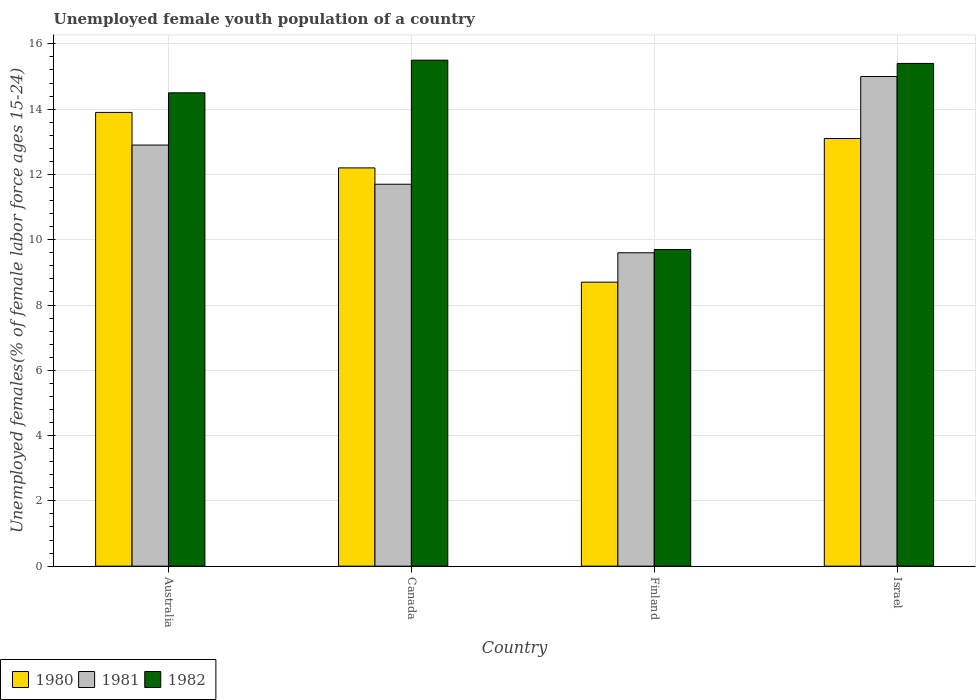How many different coloured bars are there?
Keep it short and to the point. 3. How many groups of bars are there?
Ensure brevity in your answer.  4. Are the number of bars per tick equal to the number of legend labels?
Provide a short and direct response. Yes. How many bars are there on the 1st tick from the left?
Give a very brief answer. 3. How many bars are there on the 1st tick from the right?
Provide a succinct answer. 3. What is the label of the 2nd group of bars from the left?
Offer a very short reply. Canada. Across all countries, what is the minimum percentage of unemployed female youth population in 1982?
Your response must be concise. 9.7. In which country was the percentage of unemployed female youth population in 1982 minimum?
Your answer should be compact. Finland. What is the total percentage of unemployed female youth population in 1982 in the graph?
Provide a short and direct response. 55.1. What is the difference between the percentage of unemployed female youth population in 1980 in Australia and that in Israel?
Offer a terse response. 0.8. What is the difference between the percentage of unemployed female youth population in 1981 in Australia and the percentage of unemployed female youth population in 1982 in Finland?
Offer a terse response. 3.2. What is the average percentage of unemployed female youth population in 1982 per country?
Ensure brevity in your answer.  13.77. What is the difference between the percentage of unemployed female youth population of/in 1982 and percentage of unemployed female youth population of/in 1980 in Finland?
Offer a very short reply. 1. In how many countries, is the percentage of unemployed female youth population in 1980 greater than 1.6 %?
Provide a short and direct response. 4. What is the ratio of the percentage of unemployed female youth population in 1981 in Canada to that in Israel?
Keep it short and to the point. 0.78. What is the difference between the highest and the second highest percentage of unemployed female youth population in 1982?
Your answer should be very brief. 0.9. What is the difference between the highest and the lowest percentage of unemployed female youth population in 1981?
Provide a succinct answer. 5.4. What does the 3rd bar from the left in Israel represents?
Give a very brief answer. 1982. What does the 1st bar from the right in Finland represents?
Make the answer very short. 1982. Is it the case that in every country, the sum of the percentage of unemployed female youth population in 1981 and percentage of unemployed female youth population in 1982 is greater than the percentage of unemployed female youth population in 1980?
Offer a very short reply. Yes. How many countries are there in the graph?
Your answer should be compact. 4. What is the difference between two consecutive major ticks on the Y-axis?
Your answer should be very brief. 2. Does the graph contain any zero values?
Ensure brevity in your answer.  No. Where does the legend appear in the graph?
Keep it short and to the point. Bottom left. How are the legend labels stacked?
Provide a succinct answer. Horizontal. What is the title of the graph?
Offer a terse response. Unemployed female youth population of a country. Does "1965" appear as one of the legend labels in the graph?
Give a very brief answer. No. What is the label or title of the X-axis?
Your answer should be compact. Country. What is the label or title of the Y-axis?
Ensure brevity in your answer.  Unemployed females(% of female labor force ages 15-24). What is the Unemployed females(% of female labor force ages 15-24) of 1980 in Australia?
Offer a very short reply. 13.9. What is the Unemployed females(% of female labor force ages 15-24) of 1981 in Australia?
Make the answer very short. 12.9. What is the Unemployed females(% of female labor force ages 15-24) of 1982 in Australia?
Provide a short and direct response. 14.5. What is the Unemployed females(% of female labor force ages 15-24) of 1980 in Canada?
Make the answer very short. 12.2. What is the Unemployed females(% of female labor force ages 15-24) of 1981 in Canada?
Offer a very short reply. 11.7. What is the Unemployed females(% of female labor force ages 15-24) in 1982 in Canada?
Provide a succinct answer. 15.5. What is the Unemployed females(% of female labor force ages 15-24) in 1980 in Finland?
Offer a very short reply. 8.7. What is the Unemployed females(% of female labor force ages 15-24) of 1981 in Finland?
Offer a terse response. 9.6. What is the Unemployed females(% of female labor force ages 15-24) in 1982 in Finland?
Offer a very short reply. 9.7. What is the Unemployed females(% of female labor force ages 15-24) of 1980 in Israel?
Your response must be concise. 13.1. What is the Unemployed females(% of female labor force ages 15-24) of 1982 in Israel?
Make the answer very short. 15.4. Across all countries, what is the maximum Unemployed females(% of female labor force ages 15-24) of 1980?
Keep it short and to the point. 13.9. Across all countries, what is the maximum Unemployed females(% of female labor force ages 15-24) of 1981?
Keep it short and to the point. 15. Across all countries, what is the maximum Unemployed females(% of female labor force ages 15-24) of 1982?
Provide a short and direct response. 15.5. Across all countries, what is the minimum Unemployed females(% of female labor force ages 15-24) in 1980?
Your response must be concise. 8.7. Across all countries, what is the minimum Unemployed females(% of female labor force ages 15-24) in 1981?
Make the answer very short. 9.6. Across all countries, what is the minimum Unemployed females(% of female labor force ages 15-24) of 1982?
Your answer should be very brief. 9.7. What is the total Unemployed females(% of female labor force ages 15-24) in 1980 in the graph?
Provide a short and direct response. 47.9. What is the total Unemployed females(% of female labor force ages 15-24) of 1981 in the graph?
Ensure brevity in your answer.  49.2. What is the total Unemployed females(% of female labor force ages 15-24) in 1982 in the graph?
Your answer should be compact. 55.1. What is the difference between the Unemployed females(% of female labor force ages 15-24) of 1980 in Australia and that in Canada?
Offer a terse response. 1.7. What is the difference between the Unemployed females(% of female labor force ages 15-24) in 1981 in Australia and that in Canada?
Give a very brief answer. 1.2. What is the difference between the Unemployed females(% of female labor force ages 15-24) of 1980 in Australia and that in Finland?
Keep it short and to the point. 5.2. What is the difference between the Unemployed females(% of female labor force ages 15-24) in 1982 in Australia and that in Finland?
Provide a succinct answer. 4.8. What is the difference between the Unemployed females(% of female labor force ages 15-24) in 1980 in Australia and that in Israel?
Your response must be concise. 0.8. What is the difference between the Unemployed females(% of female labor force ages 15-24) of 1981 in Canada and that in Finland?
Keep it short and to the point. 2.1. What is the difference between the Unemployed females(% of female labor force ages 15-24) of 1982 in Canada and that in Finland?
Your answer should be very brief. 5.8. What is the difference between the Unemployed females(% of female labor force ages 15-24) of 1980 in Canada and that in Israel?
Your response must be concise. -0.9. What is the difference between the Unemployed females(% of female labor force ages 15-24) in 1981 in Canada and that in Israel?
Offer a very short reply. -3.3. What is the difference between the Unemployed females(% of female labor force ages 15-24) of 1982 in Canada and that in Israel?
Keep it short and to the point. 0.1. What is the difference between the Unemployed females(% of female labor force ages 15-24) of 1981 in Australia and the Unemployed females(% of female labor force ages 15-24) of 1982 in Canada?
Your answer should be compact. -2.6. What is the difference between the Unemployed females(% of female labor force ages 15-24) in 1980 in Australia and the Unemployed females(% of female labor force ages 15-24) in 1981 in Finland?
Your answer should be compact. 4.3. What is the difference between the Unemployed females(% of female labor force ages 15-24) in 1980 in Australia and the Unemployed females(% of female labor force ages 15-24) in 1982 in Finland?
Keep it short and to the point. 4.2. What is the difference between the Unemployed females(% of female labor force ages 15-24) in 1981 in Australia and the Unemployed females(% of female labor force ages 15-24) in 1982 in Finland?
Your answer should be very brief. 3.2. What is the difference between the Unemployed females(% of female labor force ages 15-24) in 1981 in Australia and the Unemployed females(% of female labor force ages 15-24) in 1982 in Israel?
Offer a terse response. -2.5. What is the difference between the Unemployed females(% of female labor force ages 15-24) of 1980 in Canada and the Unemployed females(% of female labor force ages 15-24) of 1981 in Finland?
Your answer should be compact. 2.6. What is the difference between the Unemployed females(% of female labor force ages 15-24) in 1980 in Canada and the Unemployed females(% of female labor force ages 15-24) in 1982 in Israel?
Ensure brevity in your answer.  -3.2. What is the difference between the Unemployed females(% of female labor force ages 15-24) of 1981 in Canada and the Unemployed females(% of female labor force ages 15-24) of 1982 in Israel?
Offer a very short reply. -3.7. What is the difference between the Unemployed females(% of female labor force ages 15-24) of 1980 in Finland and the Unemployed females(% of female labor force ages 15-24) of 1981 in Israel?
Make the answer very short. -6.3. What is the difference between the Unemployed females(% of female labor force ages 15-24) of 1981 in Finland and the Unemployed females(% of female labor force ages 15-24) of 1982 in Israel?
Your answer should be compact. -5.8. What is the average Unemployed females(% of female labor force ages 15-24) of 1980 per country?
Ensure brevity in your answer.  11.97. What is the average Unemployed females(% of female labor force ages 15-24) of 1982 per country?
Offer a very short reply. 13.78. What is the difference between the Unemployed females(% of female labor force ages 15-24) of 1980 and Unemployed females(% of female labor force ages 15-24) of 1981 in Australia?
Your answer should be very brief. 1. What is the difference between the Unemployed females(% of female labor force ages 15-24) in 1981 and Unemployed females(% of female labor force ages 15-24) in 1982 in Australia?
Make the answer very short. -1.6. What is the difference between the Unemployed females(% of female labor force ages 15-24) of 1981 and Unemployed females(% of female labor force ages 15-24) of 1982 in Canada?
Provide a succinct answer. -3.8. What is the difference between the Unemployed females(% of female labor force ages 15-24) of 1980 and Unemployed females(% of female labor force ages 15-24) of 1982 in Finland?
Offer a terse response. -1. What is the difference between the Unemployed females(% of female labor force ages 15-24) in 1981 and Unemployed females(% of female labor force ages 15-24) in 1982 in Finland?
Offer a terse response. -0.1. What is the difference between the Unemployed females(% of female labor force ages 15-24) in 1980 and Unemployed females(% of female labor force ages 15-24) in 1981 in Israel?
Your answer should be very brief. -1.9. What is the ratio of the Unemployed females(% of female labor force ages 15-24) in 1980 in Australia to that in Canada?
Provide a short and direct response. 1.14. What is the ratio of the Unemployed females(% of female labor force ages 15-24) in 1981 in Australia to that in Canada?
Offer a very short reply. 1.1. What is the ratio of the Unemployed females(% of female labor force ages 15-24) in 1982 in Australia to that in Canada?
Give a very brief answer. 0.94. What is the ratio of the Unemployed females(% of female labor force ages 15-24) of 1980 in Australia to that in Finland?
Give a very brief answer. 1.6. What is the ratio of the Unemployed females(% of female labor force ages 15-24) in 1981 in Australia to that in Finland?
Your answer should be compact. 1.34. What is the ratio of the Unemployed females(% of female labor force ages 15-24) of 1982 in Australia to that in Finland?
Ensure brevity in your answer.  1.49. What is the ratio of the Unemployed females(% of female labor force ages 15-24) of 1980 in Australia to that in Israel?
Give a very brief answer. 1.06. What is the ratio of the Unemployed females(% of female labor force ages 15-24) in 1981 in Australia to that in Israel?
Give a very brief answer. 0.86. What is the ratio of the Unemployed females(% of female labor force ages 15-24) in 1982 in Australia to that in Israel?
Your response must be concise. 0.94. What is the ratio of the Unemployed females(% of female labor force ages 15-24) of 1980 in Canada to that in Finland?
Your response must be concise. 1.4. What is the ratio of the Unemployed females(% of female labor force ages 15-24) of 1981 in Canada to that in Finland?
Provide a succinct answer. 1.22. What is the ratio of the Unemployed females(% of female labor force ages 15-24) in 1982 in Canada to that in Finland?
Offer a very short reply. 1.6. What is the ratio of the Unemployed females(% of female labor force ages 15-24) in 1980 in Canada to that in Israel?
Your answer should be compact. 0.93. What is the ratio of the Unemployed females(% of female labor force ages 15-24) in 1981 in Canada to that in Israel?
Keep it short and to the point. 0.78. What is the ratio of the Unemployed females(% of female labor force ages 15-24) in 1982 in Canada to that in Israel?
Keep it short and to the point. 1.01. What is the ratio of the Unemployed females(% of female labor force ages 15-24) in 1980 in Finland to that in Israel?
Provide a succinct answer. 0.66. What is the ratio of the Unemployed females(% of female labor force ages 15-24) in 1981 in Finland to that in Israel?
Your response must be concise. 0.64. What is the ratio of the Unemployed females(% of female labor force ages 15-24) in 1982 in Finland to that in Israel?
Give a very brief answer. 0.63. What is the difference between the highest and the lowest Unemployed females(% of female labor force ages 15-24) of 1981?
Your answer should be compact. 5.4. 